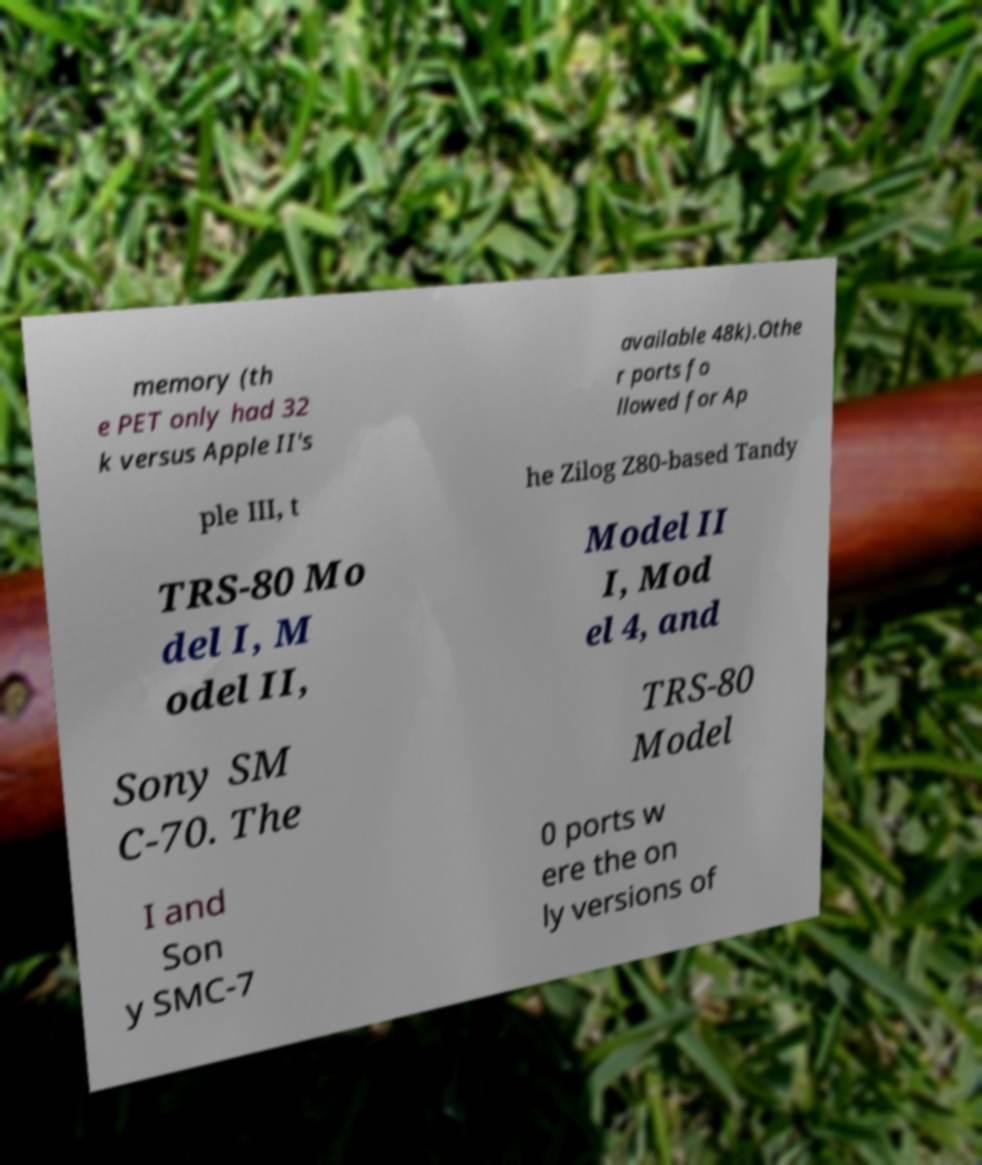Could you extract and type out the text from this image? memory (th e PET only had 32 k versus Apple II's available 48k).Othe r ports fo llowed for Ap ple III, t he Zilog Z80-based Tandy TRS-80 Mo del I, M odel II, Model II I, Mod el 4, and Sony SM C-70. The TRS-80 Model I and Son y SMC-7 0 ports w ere the on ly versions of 